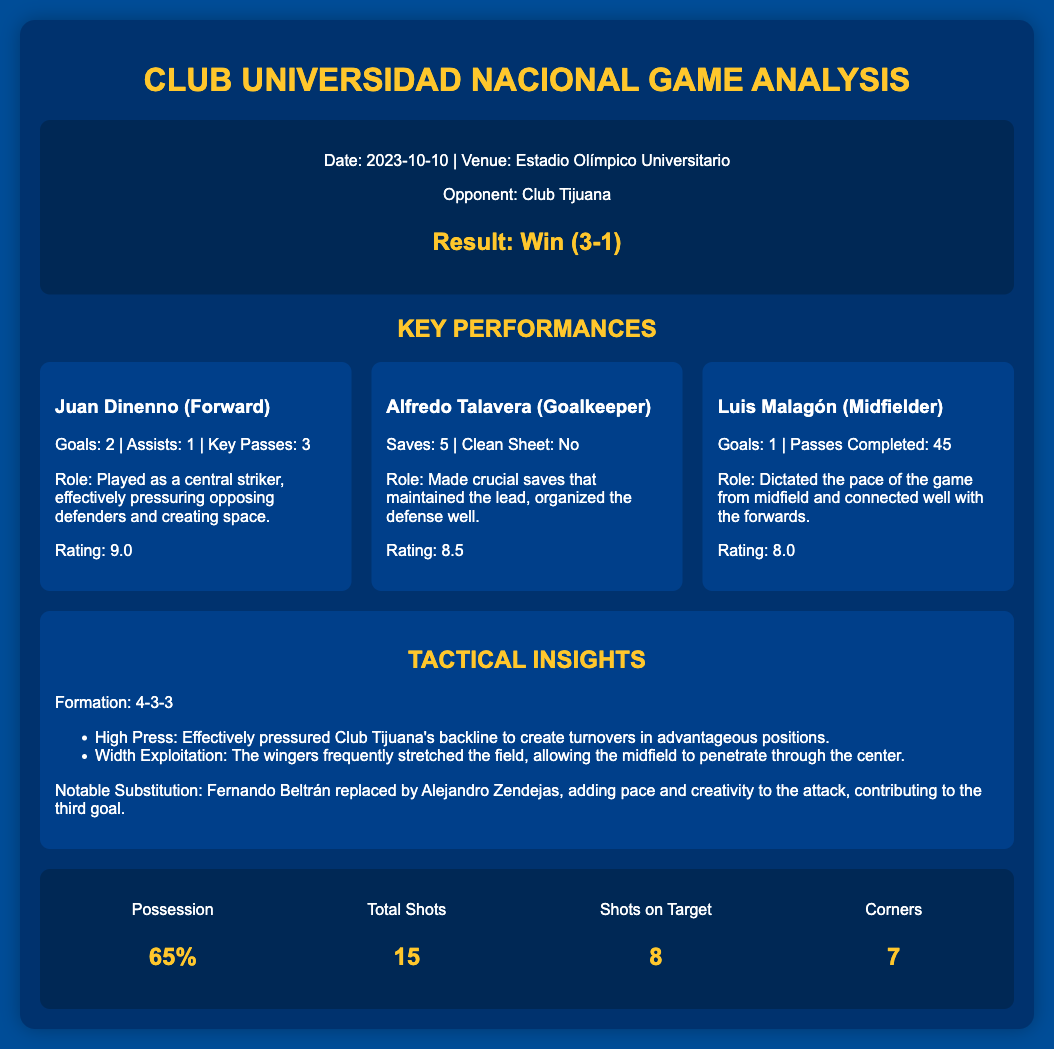What was the date of the match? The date of the match is explicitly stated in the document as 2023-10-10.
Answer: 2023-10-10 Who was the opponent in the match? The opponent is mentioned in the match info section, identifying Club Tijuana as the rival team.
Answer: Club Tijuana What was the final score of the match? The result of the match is clearly presented, indicating a win with a score of 3-1.
Answer: Win (3-1) Who scored the most goals in the match? Juan Dinenno is highlighted for scoring 2 goals, making him the top scorer in this match.
Answer: Juan Dinenno What tactical formation did Club Universidad Nacional use? The tactical formation used is noted in the tactical insights section as 4-3-3.
Answer: 4-3-3 How many total shots did Club Universidad Nacional have? The total shots statistic is provided as 15 in the stats section of the document.
Answer: 15 What was the possession percentage for Club Universidad Nacional? The possession percentage is recorded in the stats section, indicating 65%.
Answer: 65% What notable substitution was made during the match? The document specifically mentions that Fernando Beltrán was replaced by Alejandro Zendejas.
Answer: Fernando Beltrán replaced by Alejandro Zendejas What rating did Alfredo Talavera receive? The player rating for Alfredo Talavera is specifically given as 8.5.
Answer: 8.5 